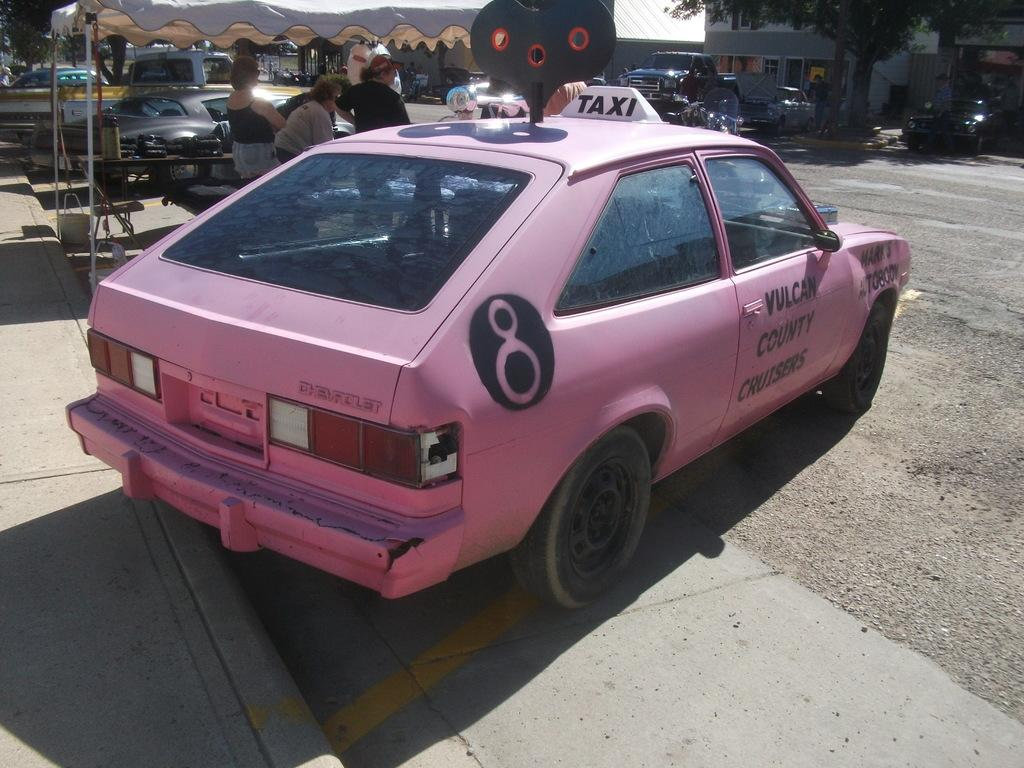What type of vehicles can be seen in the image? There are cars in the image. What type of structures are visible in the image? There are buildings in the image. What type of plant is present in the image? There is a tree in the image. Are there any living beings present in the image? Yes, there are people present in the image. How many skates are being used by the people in the image? There is no mention of skates in the image; it features cars, buildings, a tree, and people. What type of earth formation can be seen in the image? There is no specific earth formation mentioned in the image; it primarily features cars, buildings, a tree, and people. 